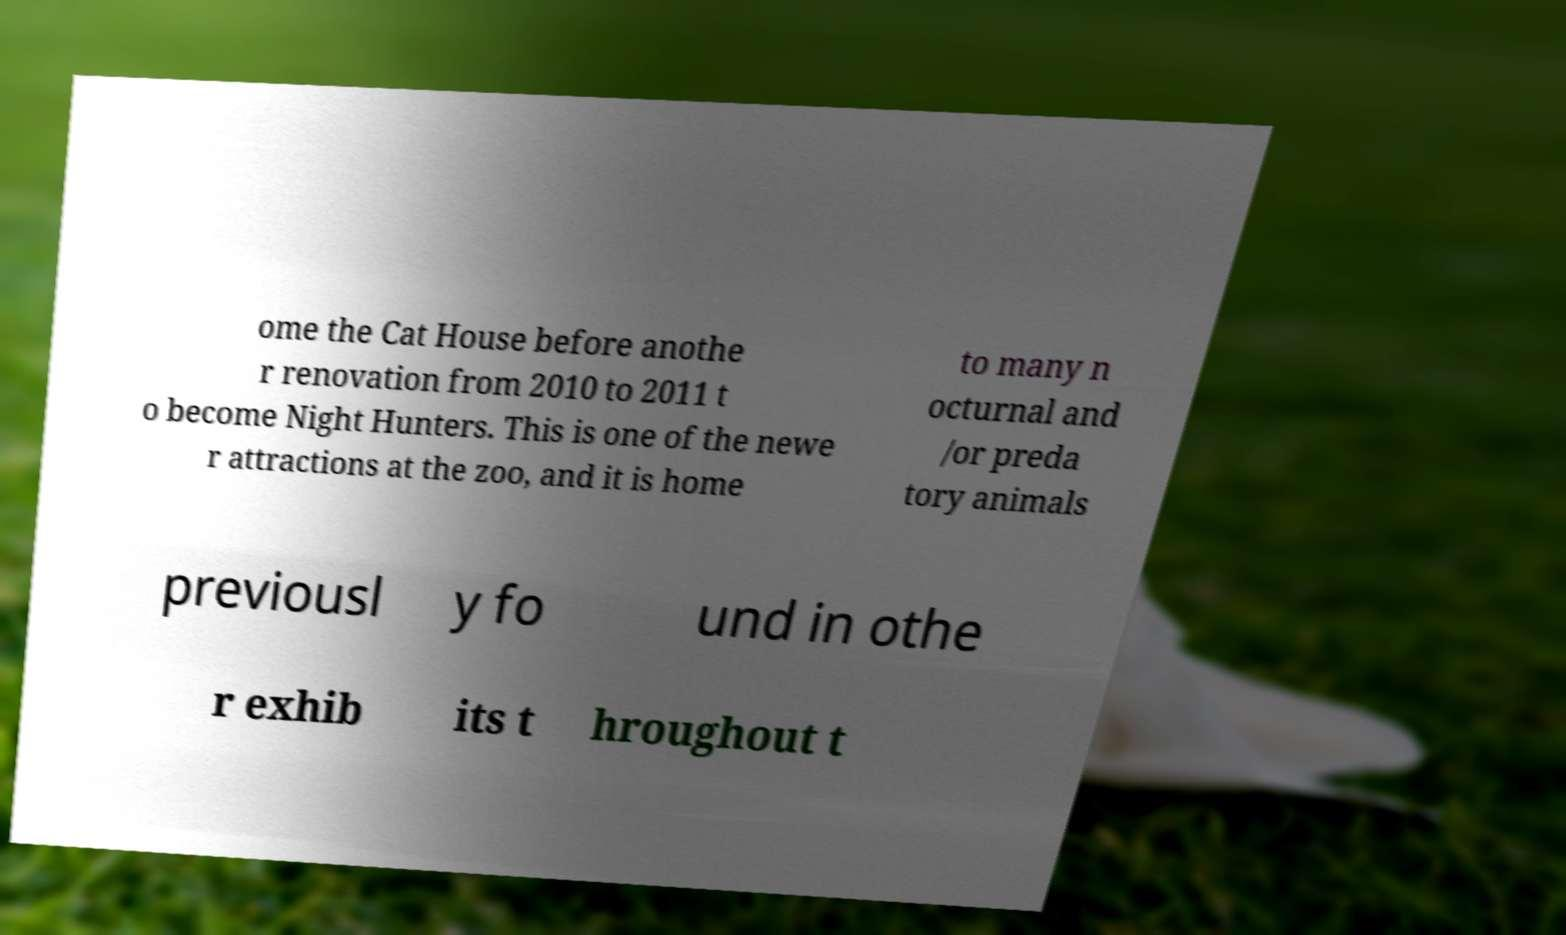Please identify and transcribe the text found in this image. ome the Cat House before anothe r renovation from 2010 to 2011 t o become Night Hunters. This is one of the newe r attractions at the zoo, and it is home to many n octurnal and /or preda tory animals previousl y fo und in othe r exhib its t hroughout t 